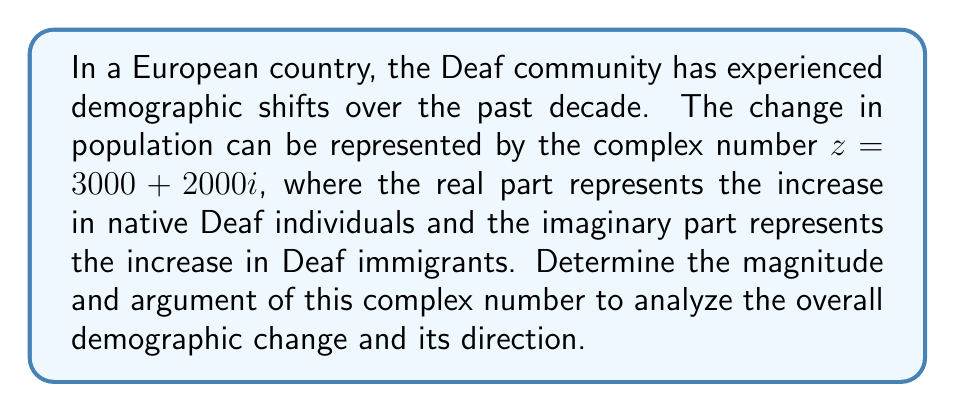Teach me how to tackle this problem. To find the magnitude and argument of the complex number $z = 3000 + 2000i$, we'll follow these steps:

1. Magnitude (modulus):
   The magnitude is given by the formula $|z| = \sqrt{a^2 + b^2}$, where $a$ is the real part and $b$ is the imaginary part.
   
   $|z| = \sqrt{3000^2 + 2000^2}$
   $|z| = \sqrt{9,000,000 + 4,000,000}$
   $|z| = \sqrt{13,000,000}$
   $|z| = 3605.55$ (rounded to 2 decimal places)

2. Argument (angle):
   The argument is given by the formula $\theta = \tan^{-1}(\frac{b}{a})$, where $a$ is the real part and $b$ is the imaginary part.
   
   $\theta = \tan^{-1}(\frac{2000}{3000})$
   $\theta = \tan^{-1}(0.6667)$
   $\theta = 0.5880$ radians
   
   To convert to degrees: $0.5880 \times \frac{180°}{\pi} = 33.69°$ (rounded to 2 decimal places)

The magnitude represents the total increase in the Deaf population, while the argument represents the direction of this change in the complex plane, indicating the relative proportion of native to immigrant growth.
Answer: Magnitude: $3605.55$, Argument: $33.69°$ 